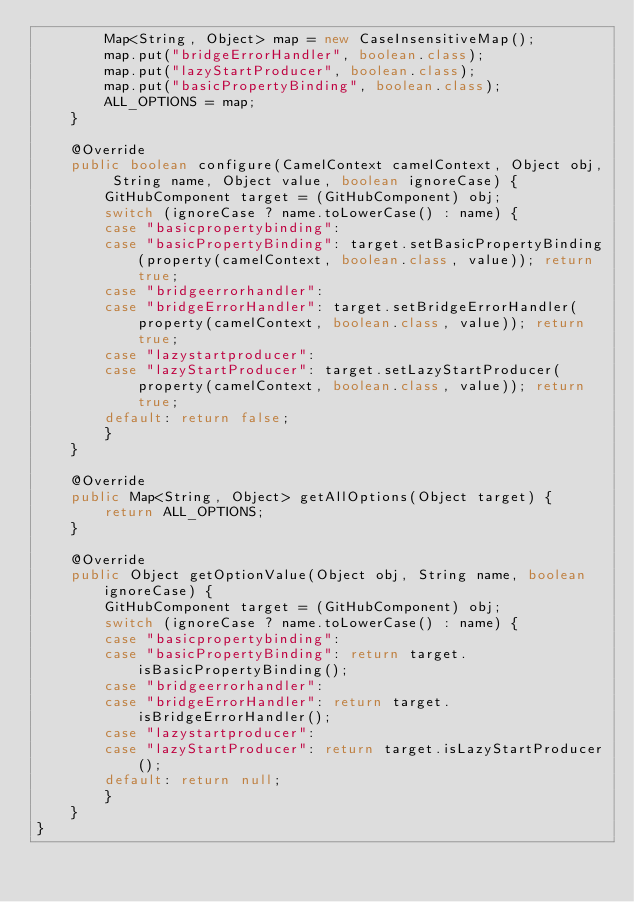<code> <loc_0><loc_0><loc_500><loc_500><_Java_>        Map<String, Object> map = new CaseInsensitiveMap();
        map.put("bridgeErrorHandler", boolean.class);
        map.put("lazyStartProducer", boolean.class);
        map.put("basicPropertyBinding", boolean.class);
        ALL_OPTIONS = map;
    }

    @Override
    public boolean configure(CamelContext camelContext, Object obj, String name, Object value, boolean ignoreCase) {
        GitHubComponent target = (GitHubComponent) obj;
        switch (ignoreCase ? name.toLowerCase() : name) {
        case "basicpropertybinding":
        case "basicPropertyBinding": target.setBasicPropertyBinding(property(camelContext, boolean.class, value)); return true;
        case "bridgeerrorhandler":
        case "bridgeErrorHandler": target.setBridgeErrorHandler(property(camelContext, boolean.class, value)); return true;
        case "lazystartproducer":
        case "lazyStartProducer": target.setLazyStartProducer(property(camelContext, boolean.class, value)); return true;
        default: return false;
        }
    }

    @Override
    public Map<String, Object> getAllOptions(Object target) {
        return ALL_OPTIONS;
    }

    @Override
    public Object getOptionValue(Object obj, String name, boolean ignoreCase) {
        GitHubComponent target = (GitHubComponent) obj;
        switch (ignoreCase ? name.toLowerCase() : name) {
        case "basicpropertybinding":
        case "basicPropertyBinding": return target.isBasicPropertyBinding();
        case "bridgeerrorhandler":
        case "bridgeErrorHandler": return target.isBridgeErrorHandler();
        case "lazystartproducer":
        case "lazyStartProducer": return target.isLazyStartProducer();
        default: return null;
        }
    }
}

</code> 